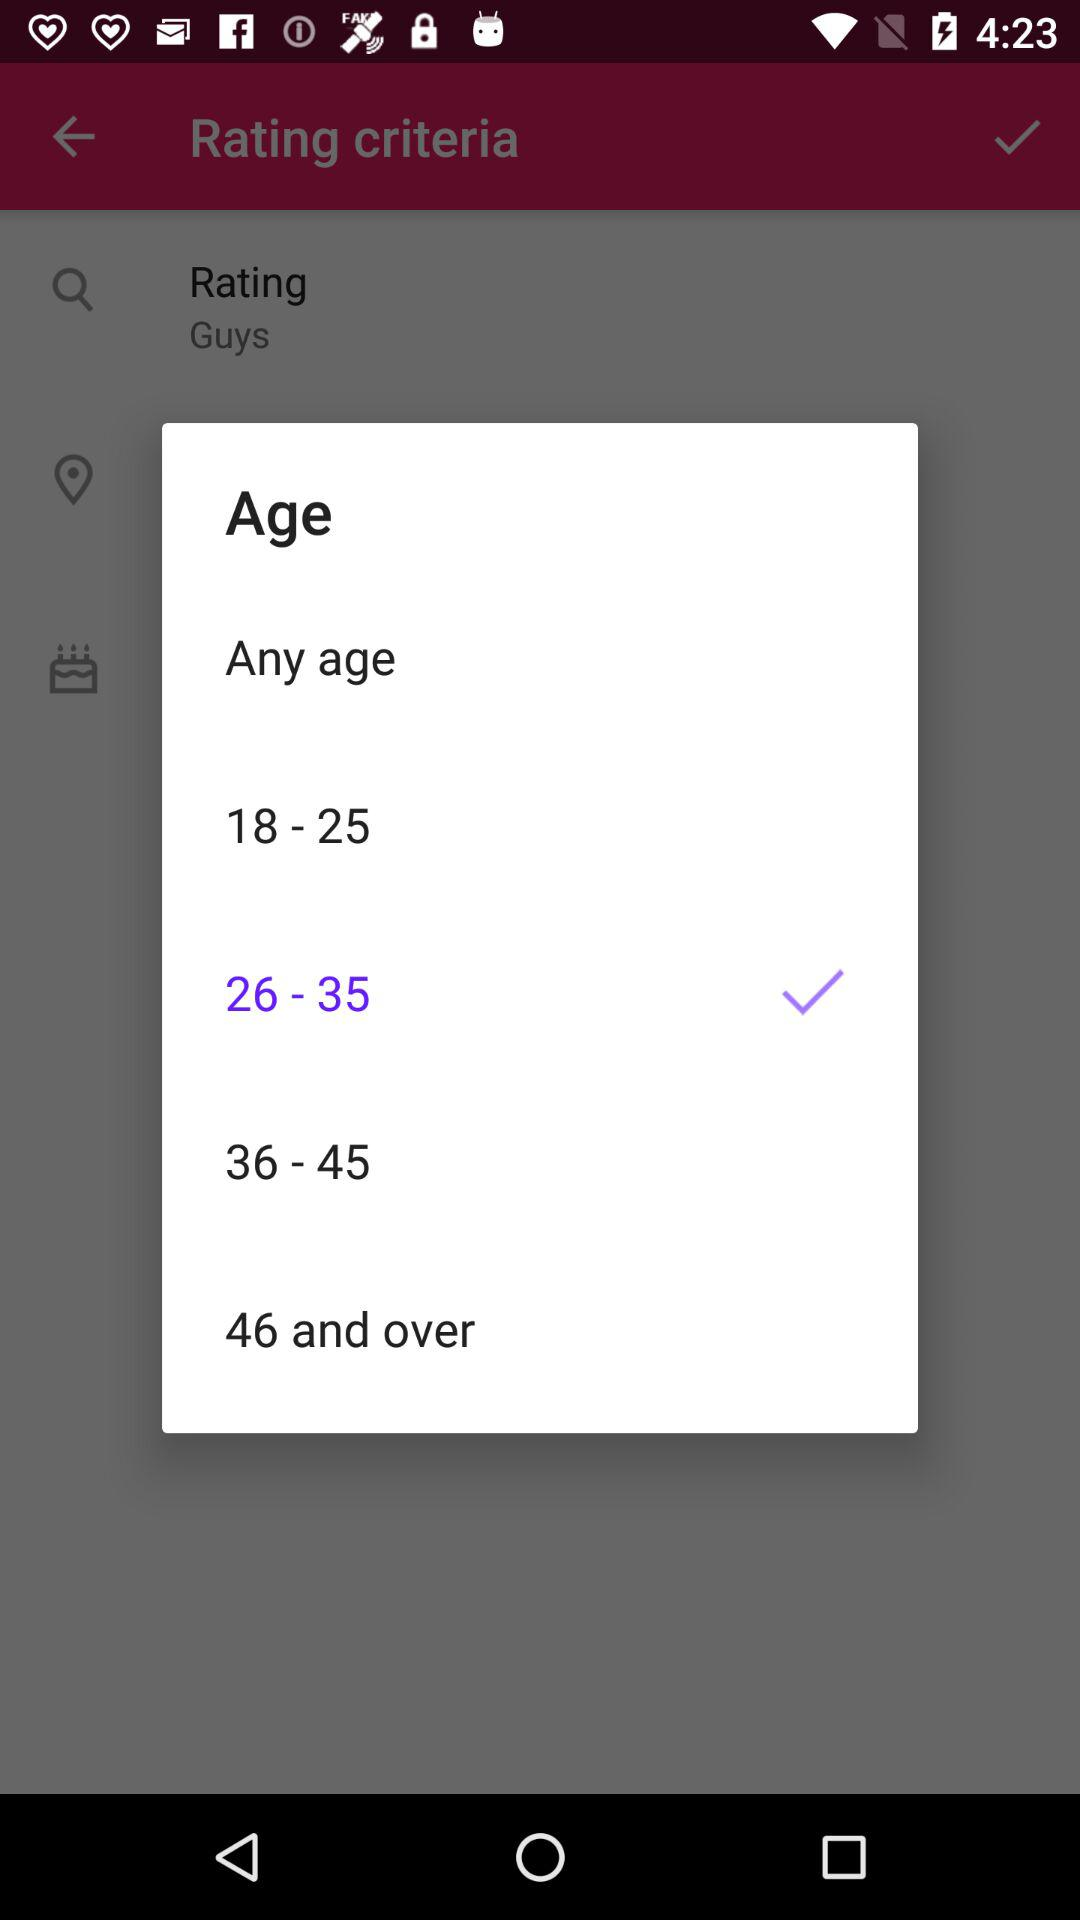What are the available options? The available options are "Any age", "18 - 25", "26 - 35", "36 - 45" and "46 and over". 